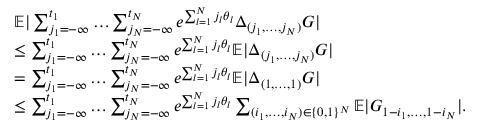Convert formula to latex. <formula><loc_0><loc_0><loc_500><loc_500>\begin{array} { r l } & { \mathbb { E } | \sum _ { j _ { 1 } = - \infty } ^ { t _ { 1 } } \dots \sum _ { j _ { N } = - \infty } ^ { t _ { N } } e ^ { \sum _ { l = 1 } ^ { N } j _ { l } \theta _ { l } } \Delta _ { ( j _ { 1 } , \dots , j _ { N } ) } G | } \\ & { \leq \sum _ { j _ { 1 } = - \infty } ^ { t _ { 1 } } \dots \sum _ { j _ { N } = - \infty } ^ { t _ { N } } e ^ { \sum _ { l = 1 } ^ { N } j _ { l } \theta _ { l } } \mathbb { E } | \Delta _ { ( j _ { 1 } , \dots , j _ { N } ) } G | } \\ & { = \sum _ { j _ { 1 } = - \infty } ^ { t _ { 1 } } \dots \sum _ { j _ { N } = - \infty } ^ { t _ { N } } e ^ { \sum _ { l = 1 } ^ { N } j _ { l } \theta _ { l } } \mathbb { E } | \Delta _ { ( 1 , \dots , 1 ) } G | } \\ & { \leq \sum _ { j _ { 1 } = - \infty } ^ { t _ { 1 } } \dots \sum _ { j _ { N } = - \infty } ^ { t _ { N } } e ^ { \sum _ { l = 1 } ^ { N } j _ { l } \theta _ { l } } \sum _ { ( i _ { 1 } , \dots , i _ { N } ) \in \{ 0 , 1 \} ^ { N } } \mathbb { E } | G _ { 1 - i _ { 1 } , \dots , 1 - i _ { N } } | . } \end{array}</formula> 